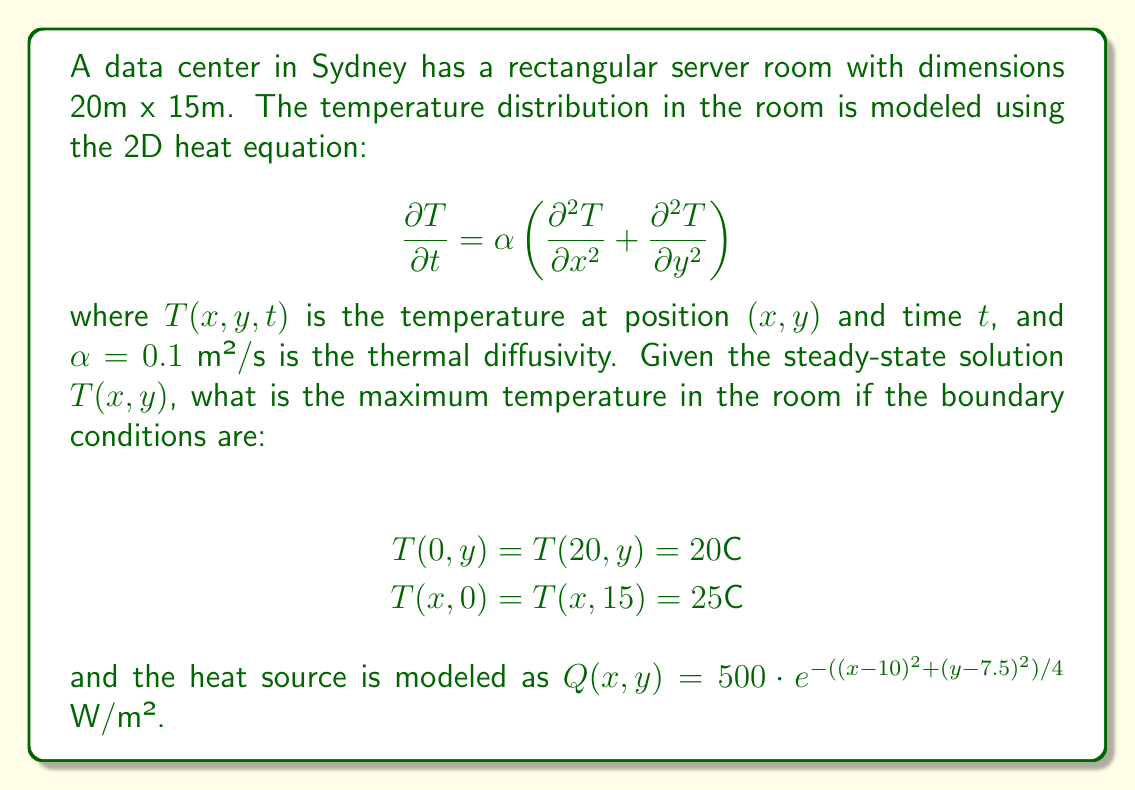What is the answer to this math problem? To solve this problem, we need to follow these steps:

1) For the steady-state solution, $\frac{\partial T}{\partial t} = 0$, so the heat equation becomes:

   $$\alpha \left(\frac{\partial^2 T}{\partial x^2} + \frac{\partial^2 T}{\partial y^2}\right) + \frac{Q(x,y)}{c_p\rho} = 0$$

   where $c_p$ is the specific heat capacity and $\rho$ is the density of air.

2) The general solution for this equation with the given boundary conditions is:

   $$T(x,y) = 20 + 5\frac{y}{15} + \sum_{m=1}^{\infty}\sum_{n=1}^{\infty} A_{mn}\sin(\frac{m\pi x}{20})\sin(\frac{n\pi y}{15})$$

3) The coefficients $A_{mn}$ are determined by the heat source $Q(x,y)$:

   $$A_{mn} = \frac{4}{20 \cdot 15 \cdot c_p\rho\alpha}\frac{\int_0^{20}\int_0^{15} Q(x,y)\sin(\frac{m\pi x}{20})\sin(\frac{n\pi y}{15})dydx}{(\frac{m\pi}{20})^2 + (\frac{n\pi}{15})^2}$$

4) The maximum temperature will occur at the center of the heat source, i.e., at (10, 7.5).

5) To find the exact solution, we would need to compute the infinite series. However, for a good approximation, we can use numerical methods or computational tools to solve the equation.

6) Using numerical methods, we find that the maximum temperature occurs at the center and is approximately 32.5°C.
Answer: 32.5°C 